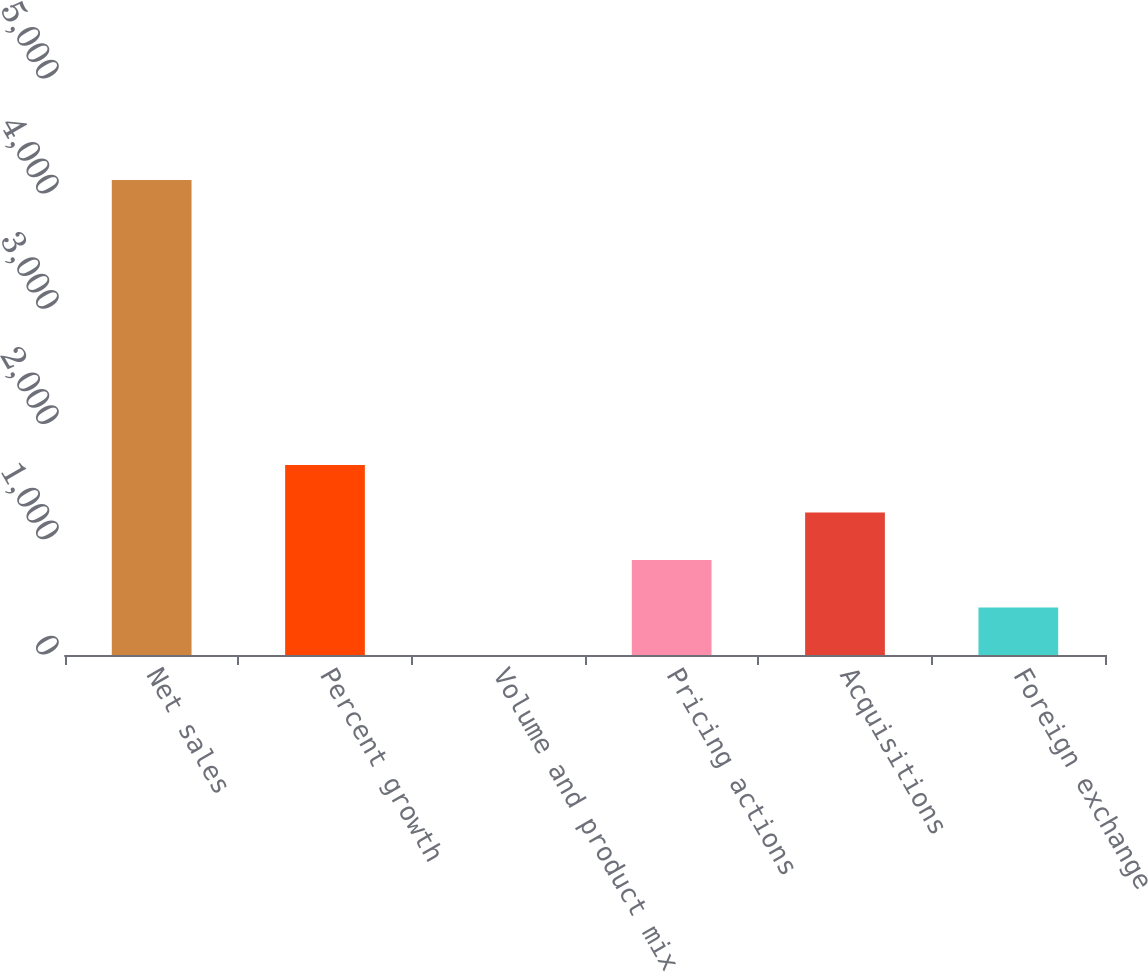<chart> <loc_0><loc_0><loc_500><loc_500><bar_chart><fcel>Net sales<fcel>Percent growth<fcel>Volume and product mix<fcel>Pricing actions<fcel>Acquisitions<fcel>Foreign exchange<nl><fcel>4123.4<fcel>1649.42<fcel>0.1<fcel>824.76<fcel>1237.09<fcel>412.43<nl></chart> 